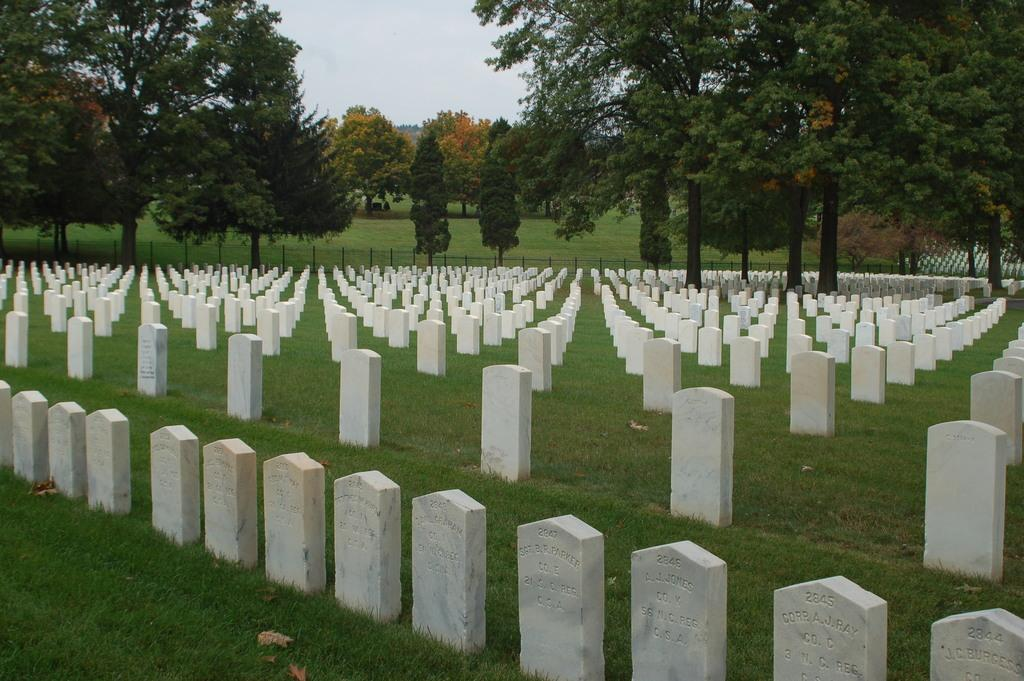What is the main setting of the image? There is a graveyard in the image. What type of natural elements can be seen in the image? There are trees in the image. What is visible in the background of the image? The sky is visible in the image. What type of cloth is draped over the gravestone in the image? There is no cloth draped over any gravestone in the image. What degree of difficulty is required to climb the trees in the image? There is no need to climb any trees in the image, and therefore, the degree of difficulty cannot be determined. 